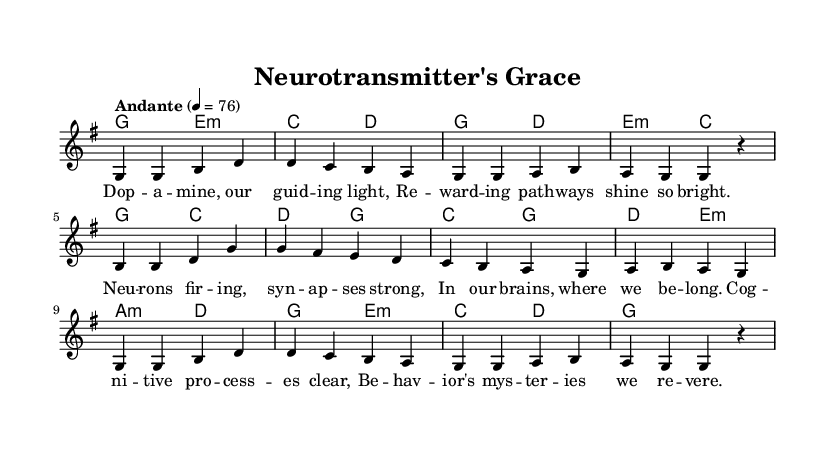What is the key signature of this music? The key signature indicated is G major, which has one sharp (F#). This is determined by looking at the key signature section at the beginning of the score.
Answer: G major What is the time signature of this music? The time signature shown in the score is 4/4. This means there are four beats per measure and a quarter note receives one beat, which can be confirmed by examining the time signature notation next to the key signature.
Answer: 4/4 What is the tempo marking of this music? The tempo marking is "Andante," which indicates a moderate walking pace. This can be found directly in the tempo indication written above the staff on the score.
Answer: Andante How many measures are there in the melody section? The melody section consists of 8 measures, which can be counted by observing the vertical lines (bar lines) separating each measure in the notation.
Answer: 8 What do the lyrics refer to in terms of neuroscience? The lyrics refer to concepts such as dopamine, rewarding pathways, and cognitive processes, directly aligning with themes in neuroscience regarding reward processing and behavior. This understanding can be gathered by reading the content of the lyrics aligned with the melody.
Answer: Neuroscience concepts Which musical element primarily reflects a sense of spirituality? The use of harmonies in the music, particularly the chord progression that creates a sense of upliftment and reflection, primarily reflects a sense of spirituality unique to religious music. This is evaluated by analyzing the chord mode and its emotional impact.
Answer: Harmonies What is the primary theme of the song's lyrics? The primary theme of the song's lyrics is the exploration of the role of dopamine and cognitive processes in behavior, blending modern neuroscience with traditional religious concepts. This is discerned from the content and wording of the lyrics themselves.
Answer: Dopamine and behavior 